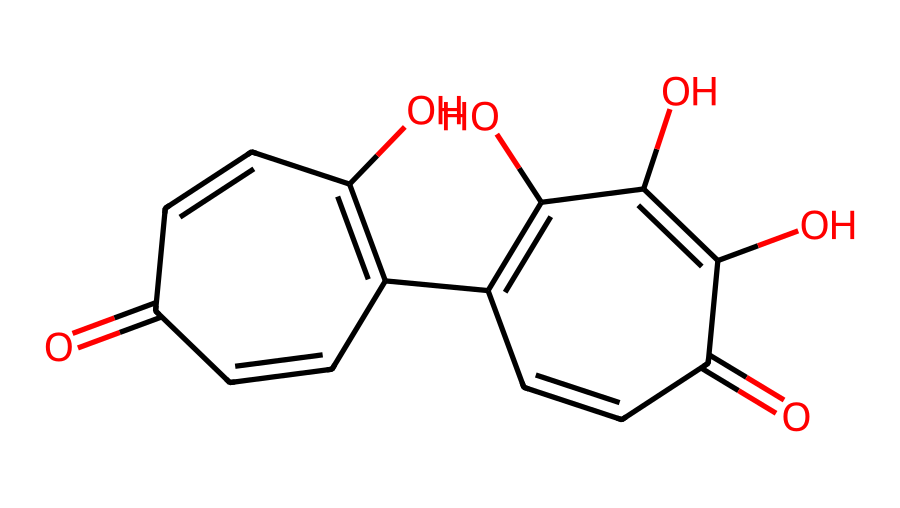How many carbon atoms are present in graphene oxide? Analyzing the provided SMILES representation, carbon (C) can be counted directly from the structure. The structure contains 15 carbon atoms in total.
Answer: 15 What functional groups are present in this chemical? By examining the chemical structure, we note that there are hydroxyl (–OH) groups and carbonyl (C=O) groups, which indicate the presence of alcohols and ketones, respectively.
Answer: hydroxyl and carbonyl How many cyclic structures are in graphene oxide? The SMILES representation shows two distinct rings: one is a six-membered ring and the other is also a six-membered ring, both evident in the structure. Thus, there are 2 cyclic structures.
Answer: 2 What is the total number of oxygen atoms in graphene oxide? Inspecting the structure reveals that there are 5 oxygen (O) atoms attached to the carbon framework as part of hydroxyl and carbonyl functionalities.
Answer: 5 What type of chemical class does graphene oxide belong to? Given its structure, characterized by multiple hydroxyl and carbonyl groups along with aromatic rings, graphene oxide is classified as a phenolic compound with nanomaterial properties.
Answer: phenolic What is the degree of unsaturation in graphene oxide? To determine degrees of unsaturation, we can count pi bonds and rings. Each ring contributes one degree of unsaturation, and each double bond (which is evident in the SMILES) contributes one. Calculating these gives a total of 6.
Answer: 6 